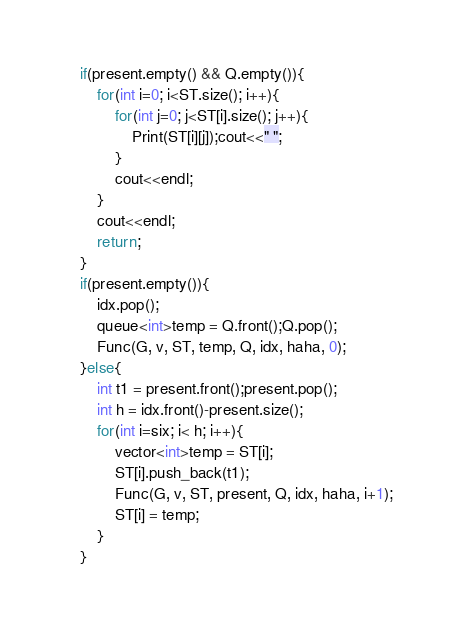Convert code to text. <code><loc_0><loc_0><loc_500><loc_500><_C++_>    if(present.empty() && Q.empty()){
        for(int i=0; i<ST.size(); i++){
            for(int j=0; j<ST[i].size(); j++){
                Print(ST[i][j]);cout<<" ";
            }
            cout<<endl;
        }
        cout<<endl;
        return;
    }
    if(present.empty()){
        idx.pop();
        queue<int>temp = Q.front();Q.pop();
        Func(G, v, ST, temp, Q, idx, haha, 0);
    }else{
        int t1 = present.front();present.pop();
        int h = idx.front()-present.size();
        for(int i=six; i< h; i++){
            vector<int>temp = ST[i];
            ST[i].push_back(t1);
            Func(G, v, ST, present, Q, idx, haha, i+1);
            ST[i] = temp;            
        }
    }</code> 